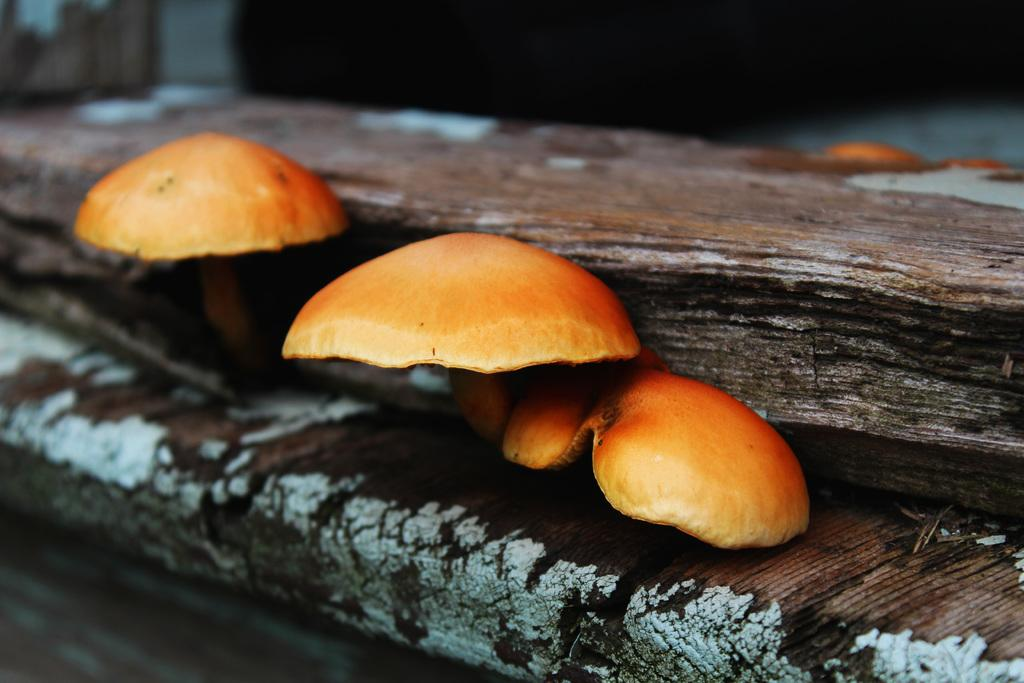What is the main object in the image? There is a wooden log in the image. Are there any additional features on the wooden log? Yes, there are mushrooms on the wooden log. Can you describe the background of the image? The background of the image is blurred. Are there any fairies sitting on the mushrooms in the image? There are no fairies present in the image. What type of seat is made from the wooden log in the image? The wooden log in the image is not being used as a seat. 